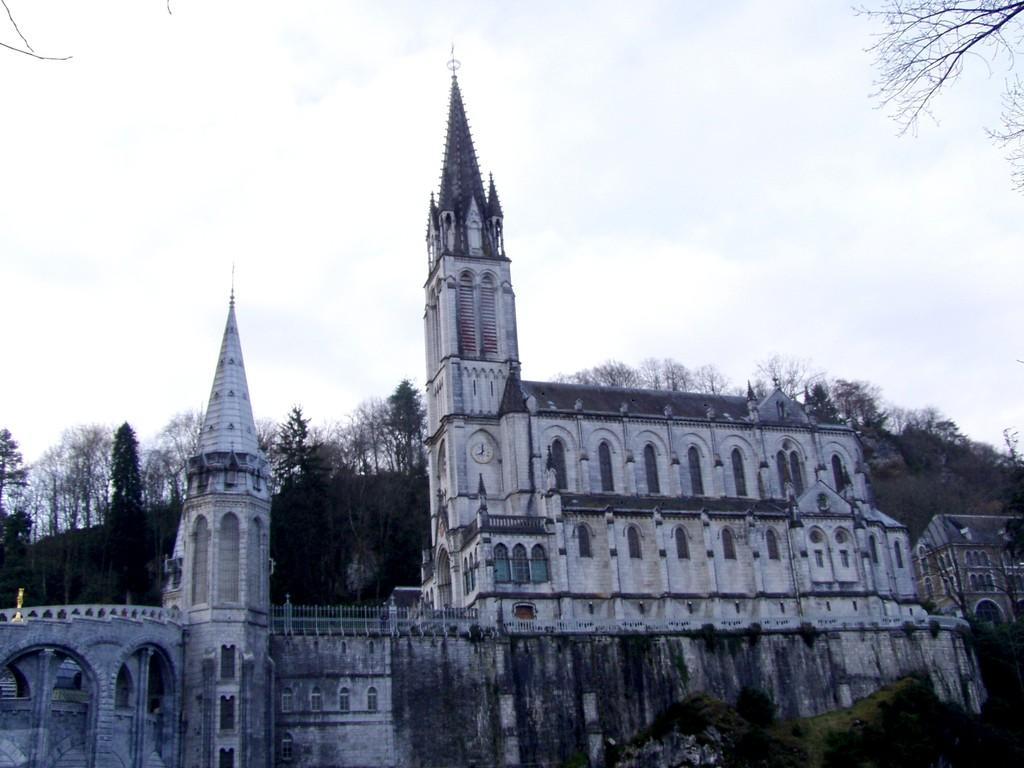Could you give a brief overview of what you see in this image? In this image I can see a castle which is white and black in color, a clock to the castle, few trees which are green in color and a mountain. In the background I can see a building and the sky. 